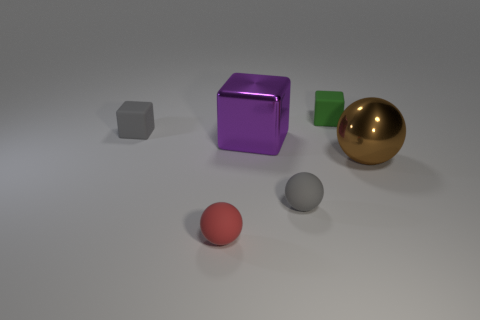What shape is the red rubber object that is the same size as the gray sphere?
Offer a terse response. Sphere. Does the large cube have the same material as the small gray cube?
Make the answer very short. No. There is another big object that is made of the same material as the brown object; what shape is it?
Your answer should be compact. Cube. Is there anything else that is the same color as the large shiny ball?
Keep it short and to the point. No. There is a small matte cube in front of the green rubber block; what color is it?
Keep it short and to the point. Gray. There is a gray object that is the same shape as the red rubber object; what material is it?
Give a very brief answer. Rubber. What number of rubber blocks have the same size as the red object?
Make the answer very short. 2. What is the shape of the purple thing?
Offer a very short reply. Cube. How big is the ball that is on the right side of the tiny red rubber object and on the left side of the large shiny sphere?
Provide a succinct answer. Small. There is a block in front of the small gray cube; what is its material?
Your response must be concise. Metal. 